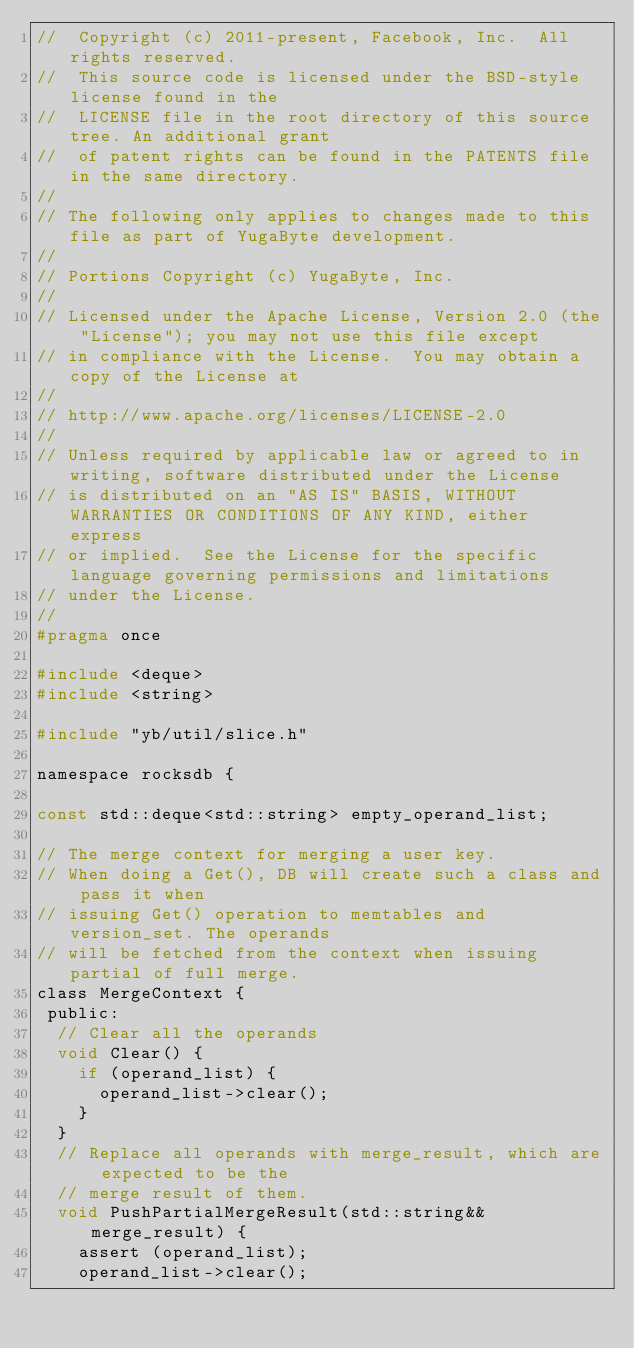Convert code to text. <code><loc_0><loc_0><loc_500><loc_500><_C_>//  Copyright (c) 2011-present, Facebook, Inc.  All rights reserved.
//  This source code is licensed under the BSD-style license found in the
//  LICENSE file in the root directory of this source tree. An additional grant
//  of patent rights can be found in the PATENTS file in the same directory.
//
// The following only applies to changes made to this file as part of YugaByte development.
//
// Portions Copyright (c) YugaByte, Inc.
//
// Licensed under the Apache License, Version 2.0 (the "License"); you may not use this file except
// in compliance with the License.  You may obtain a copy of the License at
//
// http://www.apache.org/licenses/LICENSE-2.0
//
// Unless required by applicable law or agreed to in writing, software distributed under the License
// is distributed on an "AS IS" BASIS, WITHOUT WARRANTIES OR CONDITIONS OF ANY KIND, either express
// or implied.  See the License for the specific language governing permissions and limitations
// under the License.
//
#pragma once

#include <deque>
#include <string>

#include "yb/util/slice.h"

namespace rocksdb {

const std::deque<std::string> empty_operand_list;

// The merge context for merging a user key.
// When doing a Get(), DB will create such a class and pass it when
// issuing Get() operation to memtables and version_set. The operands
// will be fetched from the context when issuing partial of full merge.
class MergeContext {
 public:
  // Clear all the operands
  void Clear() {
    if (operand_list) {
      operand_list->clear();
    }
  }
  // Replace all operands with merge_result, which are expected to be the
  // merge result of them.
  void PushPartialMergeResult(std::string&& merge_result) {
    assert (operand_list);
    operand_list->clear();</code> 